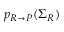<formula> <loc_0><loc_0><loc_500><loc_500>p _ { R \rightarrow P } ( \Sigma _ { R } )</formula> 